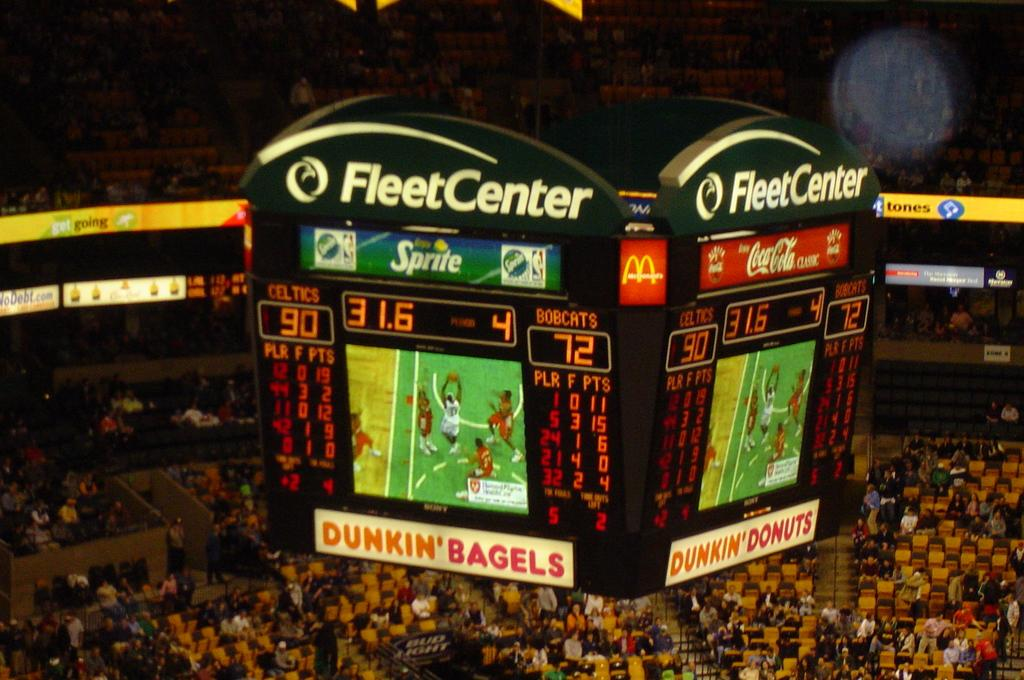Provide a one-sentence caption for the provided image. A crowd is gathered in the Fleet Center, the scoreboard hanging in the arena shows the score of the basketball game and images of the action below. 